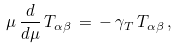Convert formula to latex. <formula><loc_0><loc_0><loc_500><loc_500>\mu \, \frac { d } { d \mu } \, T _ { \alpha \beta } \, = \, - \, \gamma _ { T } \, T _ { \alpha \beta } \, ,</formula> 